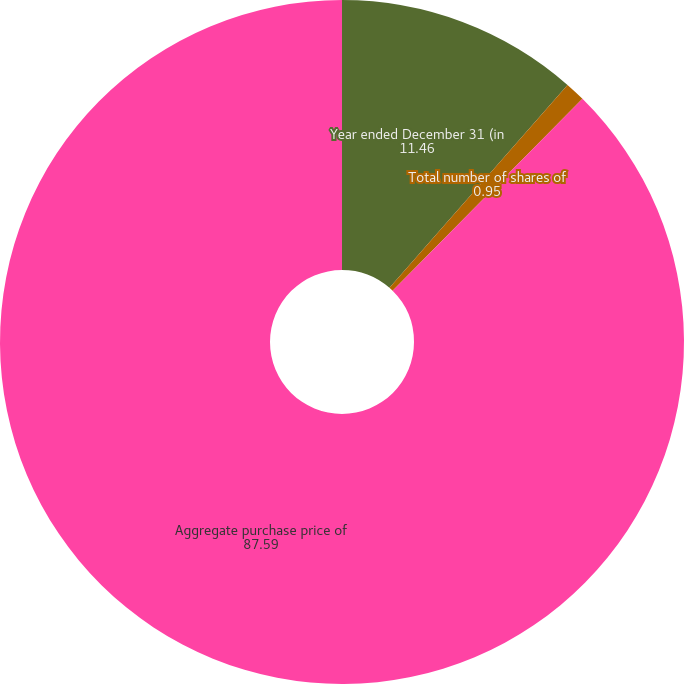<chart> <loc_0><loc_0><loc_500><loc_500><pie_chart><fcel>Year ended December 31 (in<fcel>Total number of shares of<fcel>Aggregate purchase price of<nl><fcel>11.46%<fcel>0.95%<fcel>87.59%<nl></chart> 